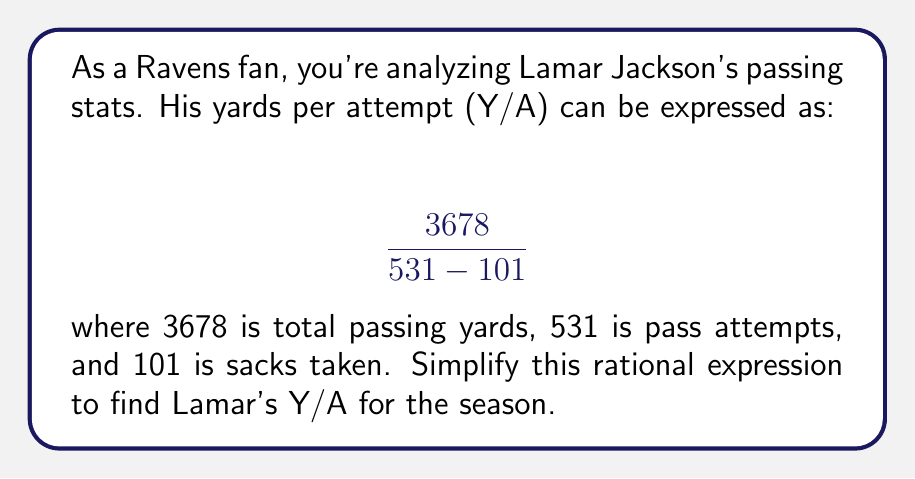Help me with this question. Let's simplify this rational expression step by step:

1) First, we need to evaluate the denominator:
   $531 - 101 = 430$

2) Now our expression looks like this:
   $$ \frac{3678}{430} $$

3) To simplify further, we need to find the greatest common divisor (GCD) of 3678 and 430.
   Using the Euclidean algorithm:
   $3678 = 8 \times 430 + 238$
   $430 = 1 \times 238 + 192$
   $238 = 1 \times 192 + 46$
   $192 = 4 \times 46 + 8$
   $46 = 5 \times 8 + 6$
   $8 = 1 \times 6 + 2$
   $6 = 3 \times 2 + 0$

   The GCD is 2.

4) Divide both numerator and denominator by 2:
   $$ \frac{3678 \div 2}{430 \div 2} = \frac{1839}{215} $$

5) This fraction cannot be simplified further.

Therefore, Lamar Jackson's yards per attempt (Y/A) is $\frac{1839}{215}$.
Answer: $\frac{1839}{215}$ 